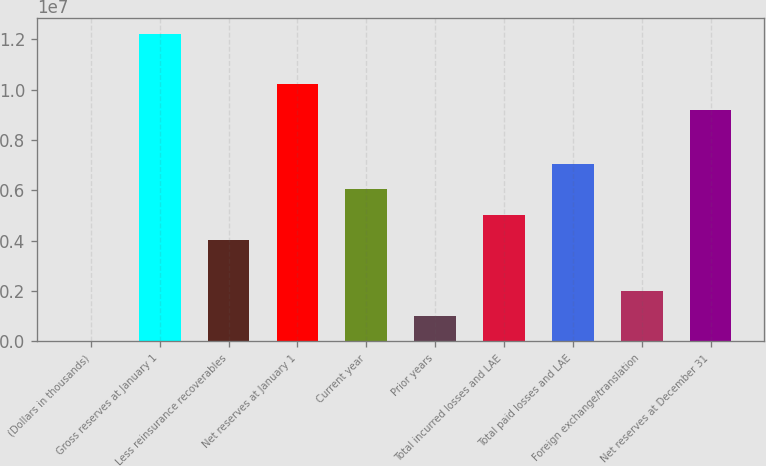<chart> <loc_0><loc_0><loc_500><loc_500><bar_chart><fcel>(Dollars in thousands)<fcel>Gross reserves at January 1<fcel>Less reinsurance recoverables<fcel>Net reserves at January 1<fcel>Current year<fcel>Prior years<fcel>Total incurred losses and LAE<fcel>Total paid losses and LAE<fcel>Foreign exchange/translation<fcel>Net reserves at December 31<nl><fcel>2013<fcel>1.22195e+07<fcel>4.02883e+06<fcel>1.02061e+07<fcel>6.04224e+06<fcel>1.00872e+06<fcel>5.03553e+06<fcel>7.04894e+06<fcel>2.01542e+06<fcel>9.19937e+06<nl></chart> 